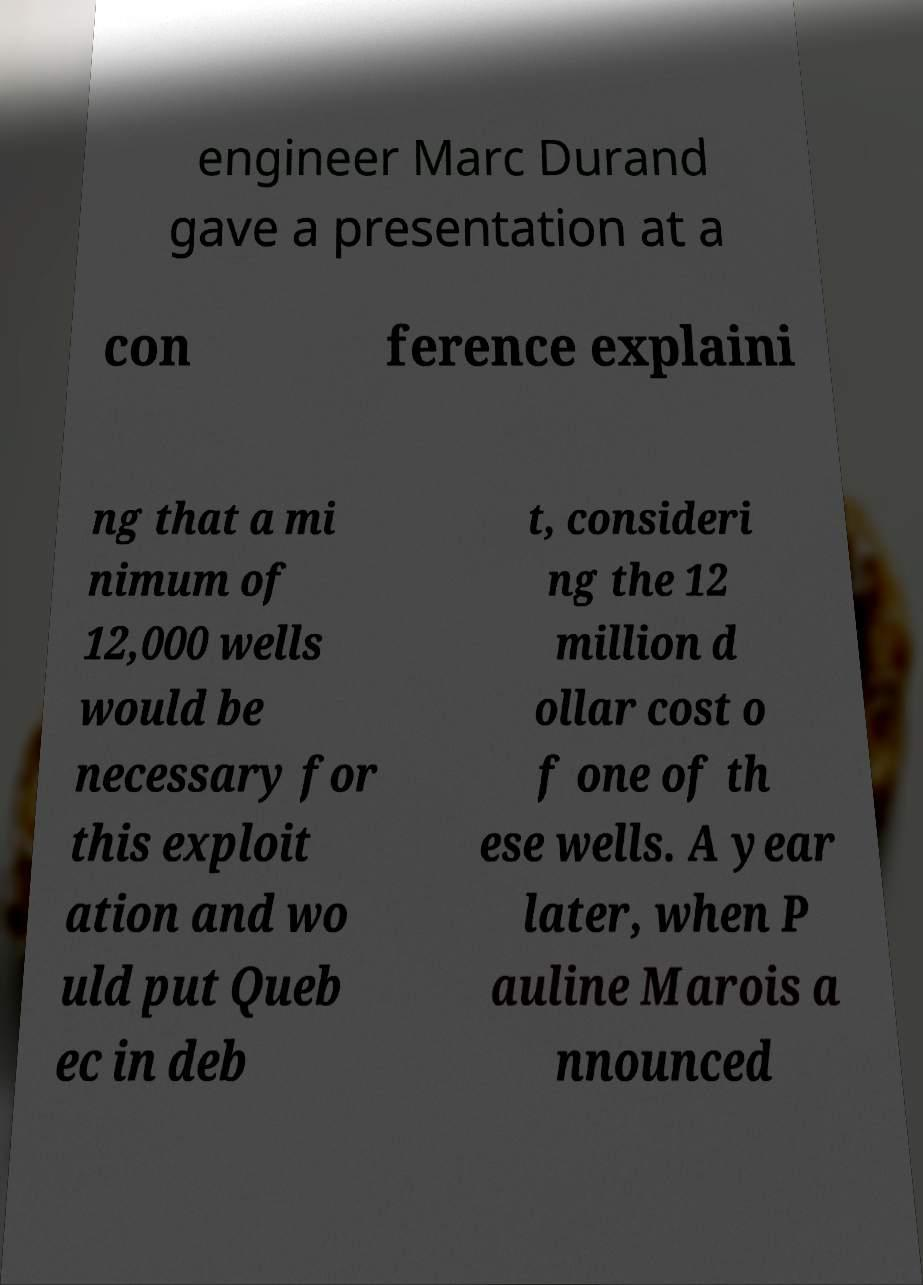There's text embedded in this image that I need extracted. Can you transcribe it verbatim? engineer Marc Durand gave a presentation at a con ference explaini ng that a mi nimum of 12,000 wells would be necessary for this exploit ation and wo uld put Queb ec in deb t, consideri ng the 12 million d ollar cost o f one of th ese wells. A year later, when P auline Marois a nnounced 